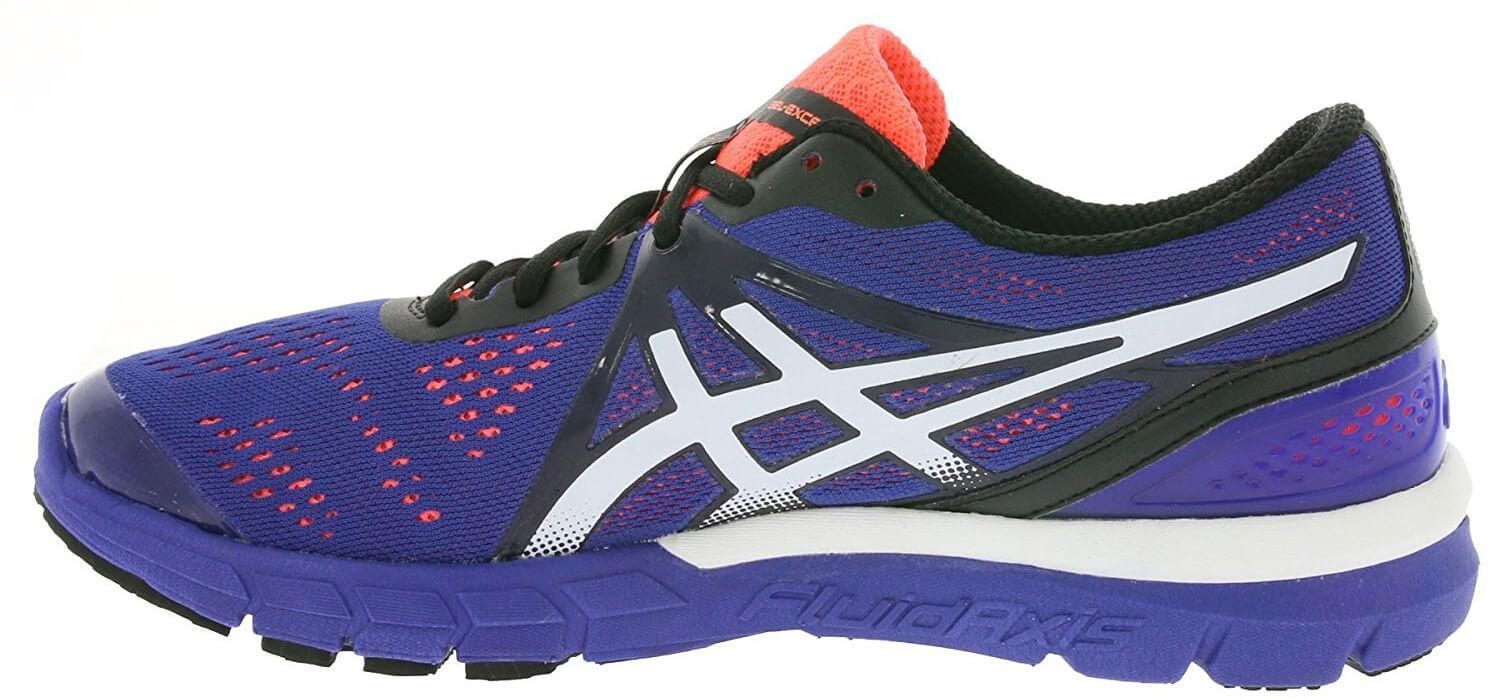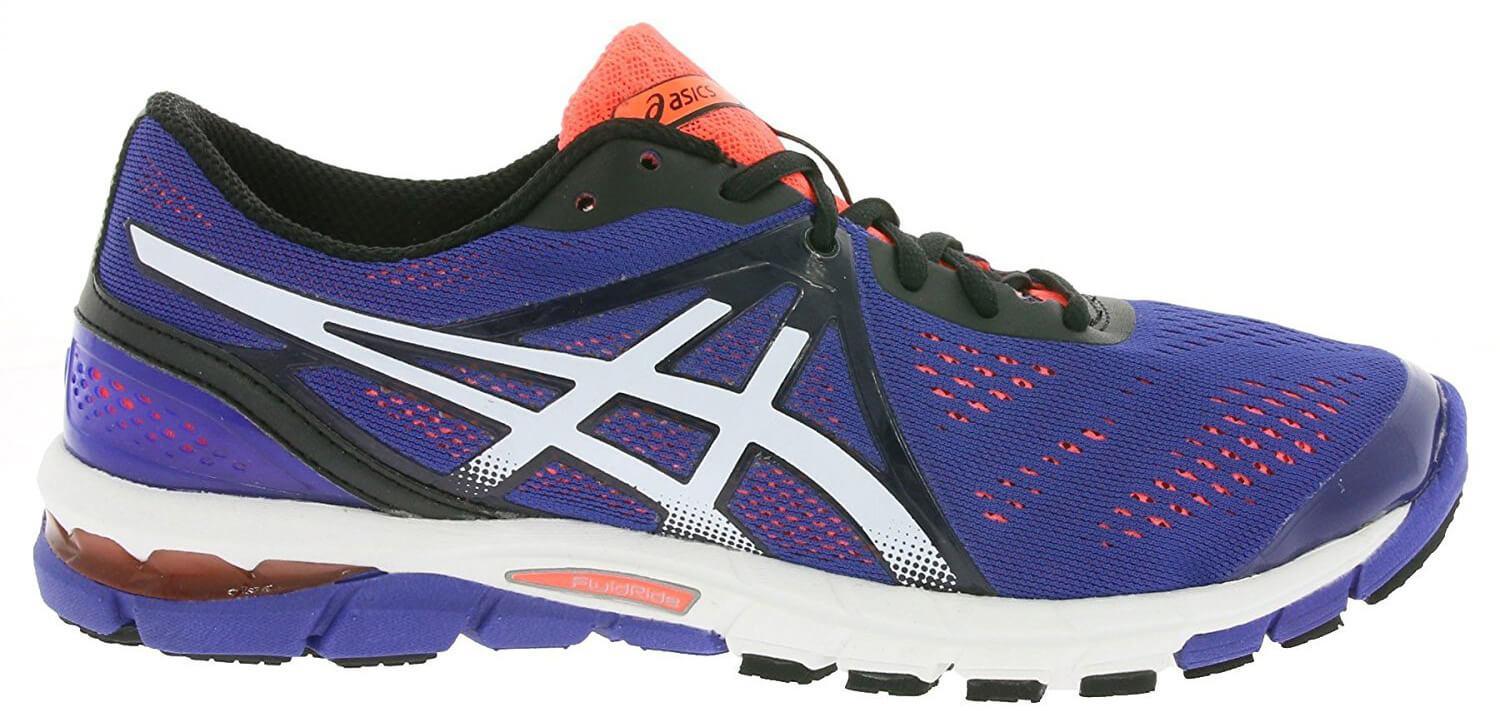The first image is the image on the left, the second image is the image on the right. For the images displayed, is the sentence "At least one shoe is purple with white and orange trim." factually correct? Answer yes or no. Yes. 